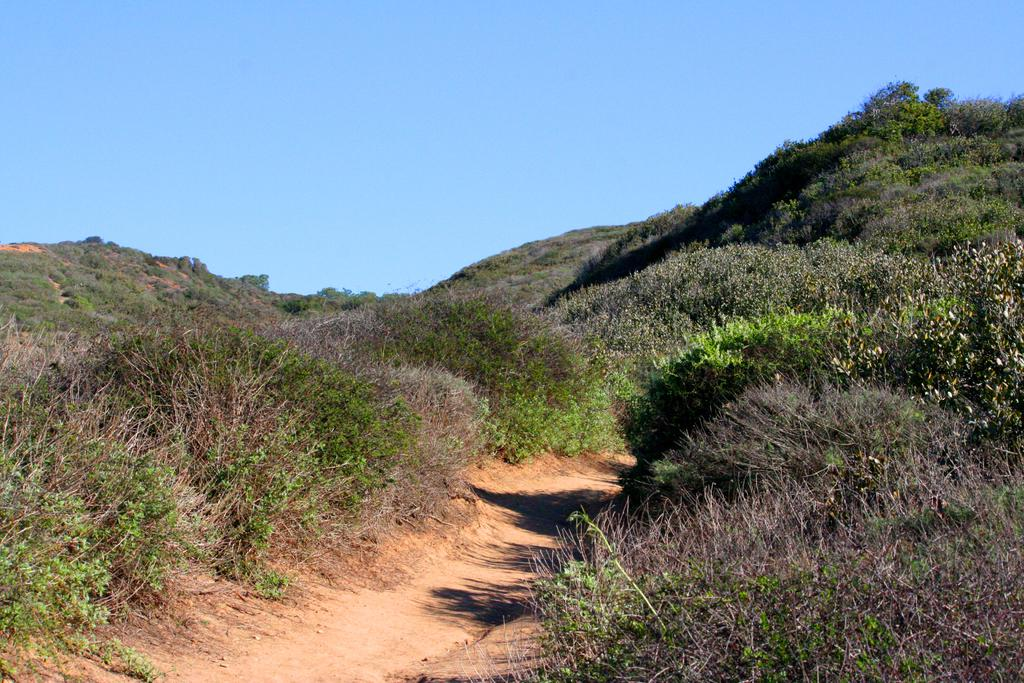What type of vegetation can be seen in the image? There are plants and trees in the image. What type of landscape feature is present in the image? There are hills in the image. Can you describe the natural environment depicted in the image? The image features plants, trees, and hills, which suggests a natural, outdoor setting. How many women are walking down the alley in the image? There is no alley or women present in the image. What type of ducks can be seen swimming in the pond in the image? There is no pond or ducks present in the image. 